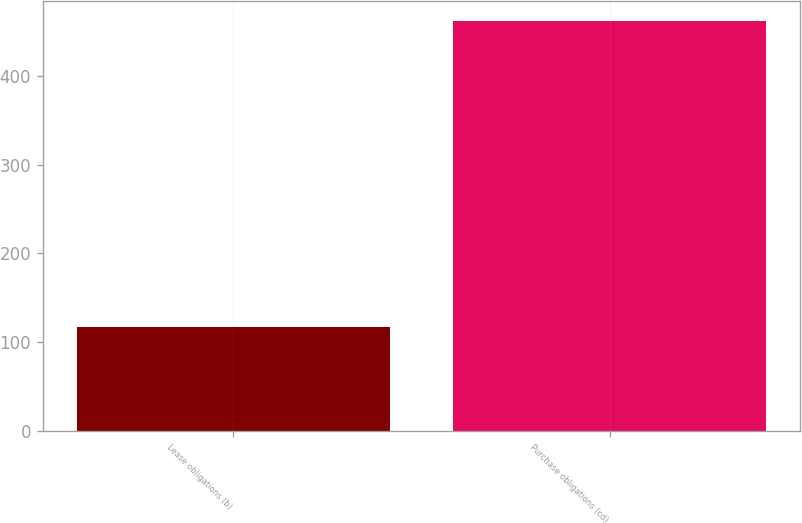Convert chart to OTSL. <chart><loc_0><loc_0><loc_500><loc_500><bar_chart><fcel>Lease obligations (b)<fcel>Purchase obligations (cd)<nl><fcel>117<fcel>462<nl></chart> 